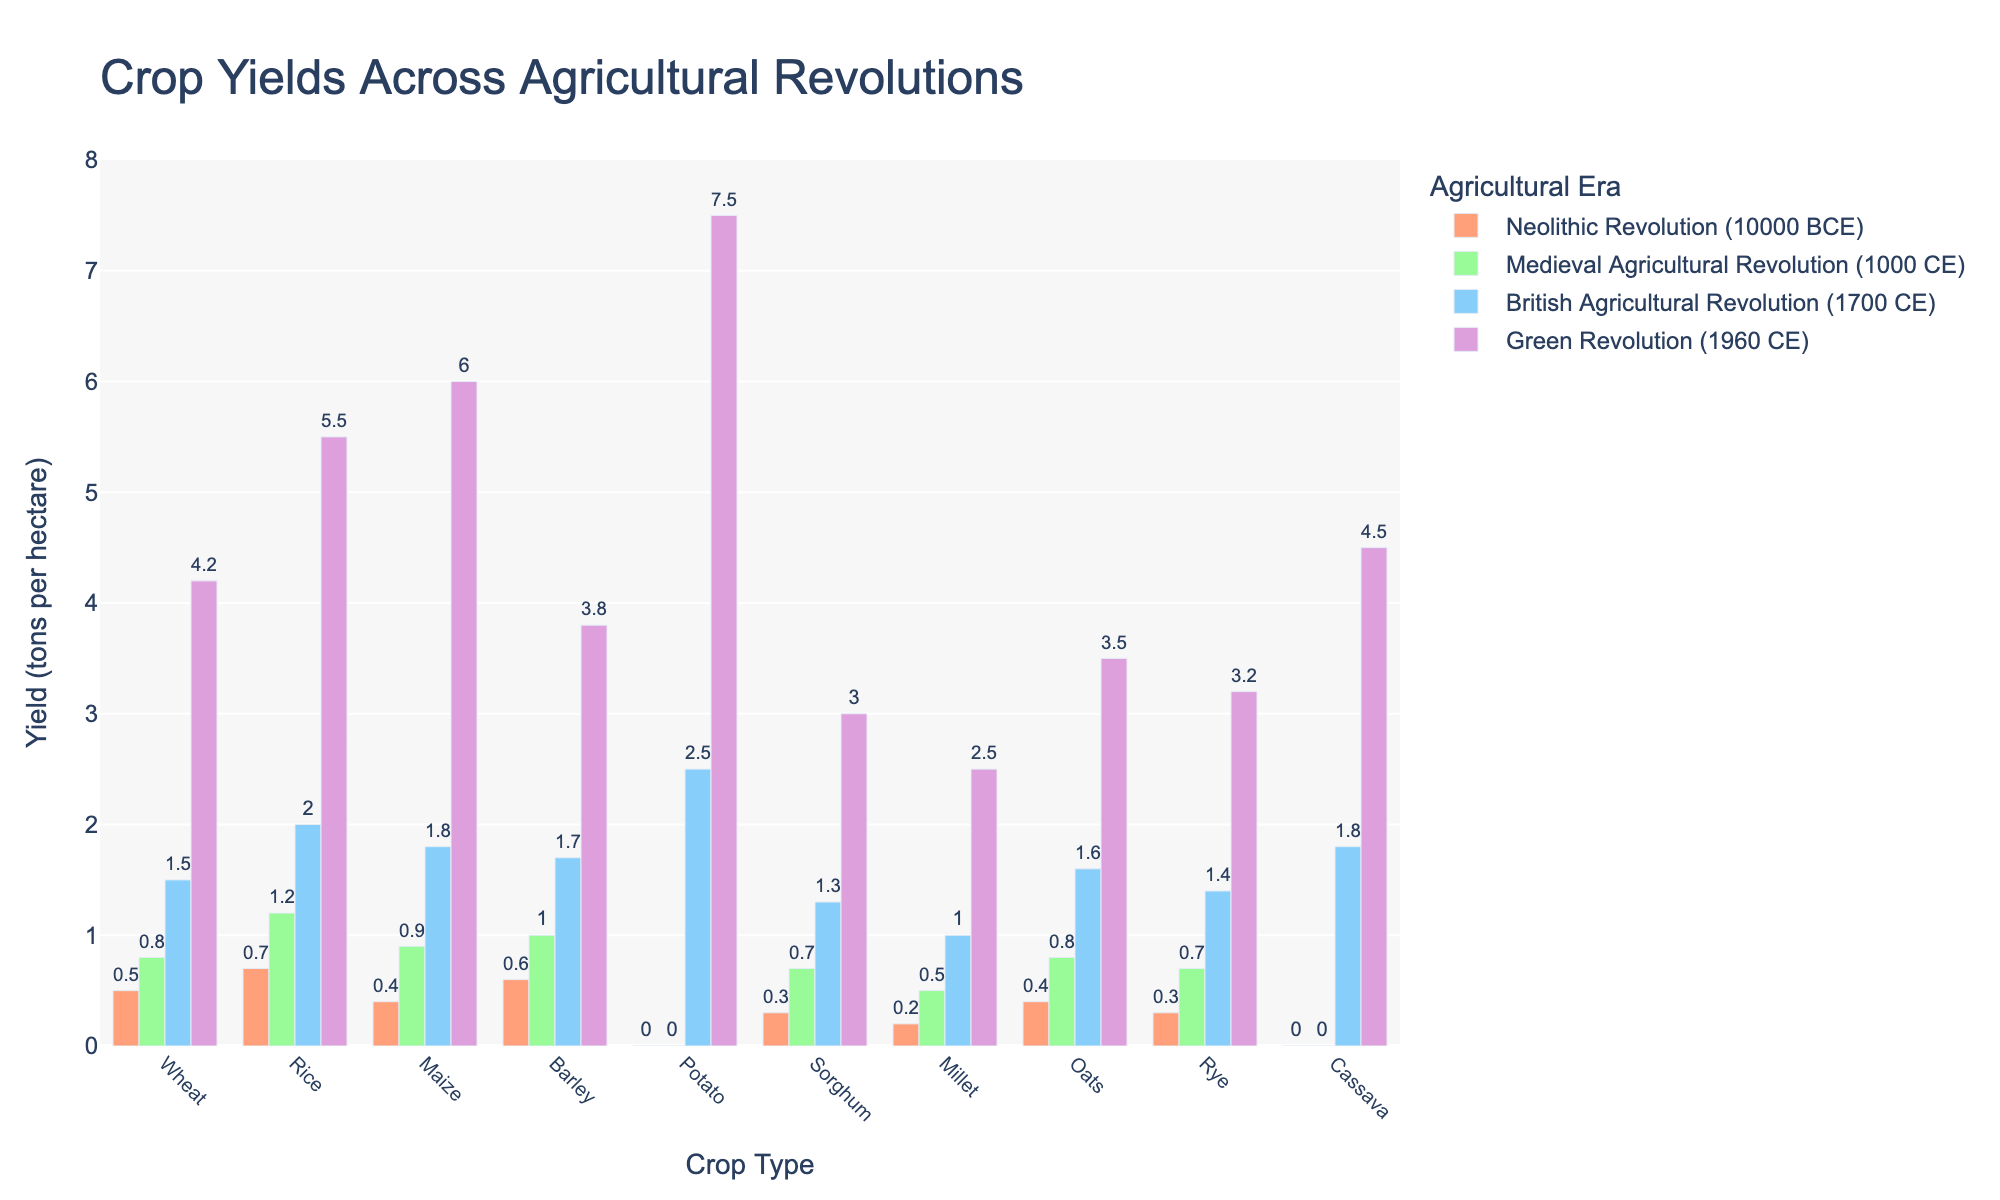Which crop had the highest yield during the Green Revolution? To find this, look at the heights of the bars corresponding to the Green Revolution for each crop. The highest bar represents the crop with the maximum yield. The potato bar is the tallest.
Answer: Potato What is the total yield of maize across all four agricultural revolutions? Summing up the yields of maize during the Neolithic, Medieval, British, and Green revolutions gives 0.4 + 0.9 + 1.8 + 6.0.
Answer: 9.1 Which agricultural era saw the highest average crop yield? Calculate the average yield for each era by summing the yields for all crops and dividing by the number of crops. Compare these to determine the highest average. The Green Revolution shows the highest average yield.
Answer: Green Revolution How does the yield of wheat in the British Agricultural Revolution compare to its yield in the Medieval Agricultural Revolution? Locate the bars for wheat in both the British Agricultural Revolution and the Medieval Agricultural Revolution. The yield in the British era (1.5) is higher than in the Medieval era (0.8).
Answer: Higher What is the difference in yield between rice and barley in the Green Revolution? Look at the bars for rice and barley in the Green Revolution. Calculate the difference: 5.5 (rice) - 3.8 (barley).
Answer: 1.7 Which crop showed the greatest increase in yield from the Neolithic Revolution to the Green Revolution? For each crop, calculate the difference between its yield in the Neolithic Revolution and the Green Revolution, then identify the maximum difference. Potato showed the greatest increase from 0.0 to 7.5, i.e., 7.5.
Answer: Potato What is the average yield of barley during the Medieval and British Agricultural Revolutions combined? Add barley yields for the Medieval and British Revolutions (1.0 + 1.7), then divide by 2 for the average.
Answer: 1.35 Was there any crop that had zero yield during both the Neolithic and Medieval Agricultural Revolutions? Find crops with bars at zero height for both the Neolithic and Medieval Agricultural Revolutions. Potato and cassava meet this criterion.
Answer: Potato, Cassava Which revolution saw the first significant increase in the yield of potato? Examine the bars representing potato across all revolutions. Potato yield remains zero until the British Agricultural Revolution, when it jumps to 2.5.
Answer: British Agricultural Revolution 